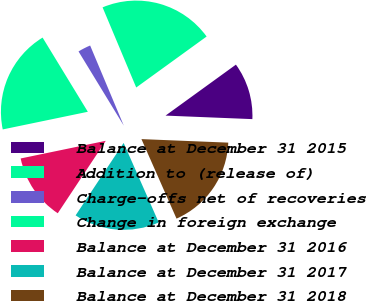Convert chart. <chart><loc_0><loc_0><loc_500><loc_500><pie_chart><fcel>Balance at December 31 2015<fcel>Addition to (release of)<fcel>Charge-offs net of recoveries<fcel>Change in foreign exchange<fcel>Balance at December 31 2016<fcel>Balance at December 31 2017<fcel>Balance at December 31 2018<nl><fcel>10.62%<fcel>21.35%<fcel>2.39%<fcel>19.54%<fcel>12.43%<fcel>15.93%<fcel>17.74%<nl></chart> 